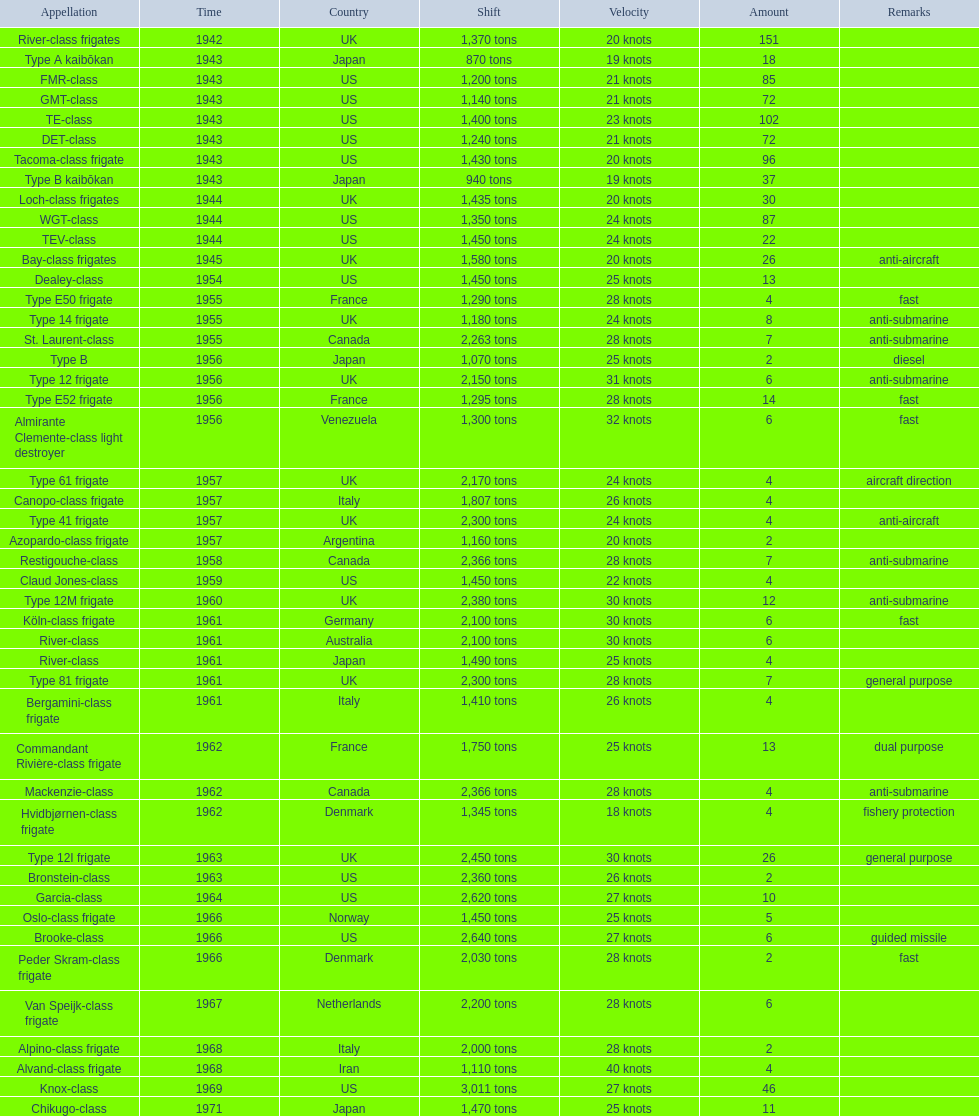What is the difference in speed for the gmt-class and the te-class? 2 knots. 